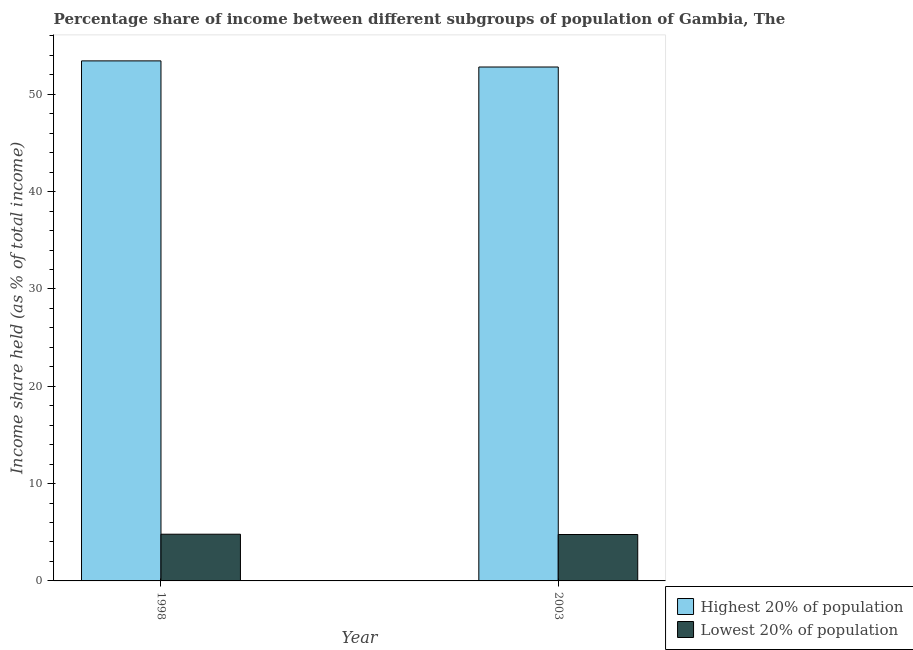How many different coloured bars are there?
Keep it short and to the point. 2. How many groups of bars are there?
Offer a very short reply. 2. Are the number of bars per tick equal to the number of legend labels?
Your response must be concise. Yes. How many bars are there on the 2nd tick from the left?
Make the answer very short. 2. What is the label of the 1st group of bars from the left?
Keep it short and to the point. 1998. In how many cases, is the number of bars for a given year not equal to the number of legend labels?
Keep it short and to the point. 0. Across all years, what is the maximum income share held by lowest 20% of the population?
Give a very brief answer. 4.8. Across all years, what is the minimum income share held by highest 20% of the population?
Offer a terse response. 52.81. In which year was the income share held by highest 20% of the population maximum?
Provide a succinct answer. 1998. What is the total income share held by lowest 20% of the population in the graph?
Your answer should be very brief. 9.57. What is the difference between the income share held by lowest 20% of the population in 1998 and that in 2003?
Make the answer very short. 0.03. What is the difference between the income share held by lowest 20% of the population in 1998 and the income share held by highest 20% of the population in 2003?
Give a very brief answer. 0.03. What is the average income share held by highest 20% of the population per year?
Make the answer very short. 53.12. In the year 2003, what is the difference between the income share held by highest 20% of the population and income share held by lowest 20% of the population?
Your response must be concise. 0. In how many years, is the income share held by highest 20% of the population greater than 22 %?
Provide a short and direct response. 2. What is the ratio of the income share held by highest 20% of the population in 1998 to that in 2003?
Offer a very short reply. 1.01. What does the 1st bar from the left in 2003 represents?
Make the answer very short. Highest 20% of population. What does the 2nd bar from the right in 1998 represents?
Offer a terse response. Highest 20% of population. Are all the bars in the graph horizontal?
Offer a very short reply. No. How many years are there in the graph?
Offer a very short reply. 2. Does the graph contain grids?
Your answer should be very brief. No. What is the title of the graph?
Provide a short and direct response. Percentage share of income between different subgroups of population of Gambia, The. Does "RDB concessional" appear as one of the legend labels in the graph?
Your answer should be very brief. No. What is the label or title of the X-axis?
Your response must be concise. Year. What is the label or title of the Y-axis?
Make the answer very short. Income share held (as % of total income). What is the Income share held (as % of total income) of Highest 20% of population in 1998?
Provide a short and direct response. 53.44. What is the Income share held (as % of total income) in Highest 20% of population in 2003?
Your answer should be compact. 52.81. What is the Income share held (as % of total income) in Lowest 20% of population in 2003?
Offer a terse response. 4.77. Across all years, what is the maximum Income share held (as % of total income) in Highest 20% of population?
Offer a very short reply. 53.44. Across all years, what is the maximum Income share held (as % of total income) in Lowest 20% of population?
Offer a very short reply. 4.8. Across all years, what is the minimum Income share held (as % of total income) in Highest 20% of population?
Provide a succinct answer. 52.81. Across all years, what is the minimum Income share held (as % of total income) of Lowest 20% of population?
Provide a succinct answer. 4.77. What is the total Income share held (as % of total income) in Highest 20% of population in the graph?
Keep it short and to the point. 106.25. What is the total Income share held (as % of total income) in Lowest 20% of population in the graph?
Ensure brevity in your answer.  9.57. What is the difference between the Income share held (as % of total income) in Highest 20% of population in 1998 and that in 2003?
Provide a succinct answer. 0.63. What is the difference between the Income share held (as % of total income) of Lowest 20% of population in 1998 and that in 2003?
Make the answer very short. 0.03. What is the difference between the Income share held (as % of total income) in Highest 20% of population in 1998 and the Income share held (as % of total income) in Lowest 20% of population in 2003?
Offer a very short reply. 48.67. What is the average Income share held (as % of total income) in Highest 20% of population per year?
Provide a short and direct response. 53.12. What is the average Income share held (as % of total income) of Lowest 20% of population per year?
Keep it short and to the point. 4.79. In the year 1998, what is the difference between the Income share held (as % of total income) in Highest 20% of population and Income share held (as % of total income) in Lowest 20% of population?
Give a very brief answer. 48.64. In the year 2003, what is the difference between the Income share held (as % of total income) of Highest 20% of population and Income share held (as % of total income) of Lowest 20% of population?
Your answer should be very brief. 48.04. What is the ratio of the Income share held (as % of total income) of Highest 20% of population in 1998 to that in 2003?
Provide a succinct answer. 1.01. What is the difference between the highest and the second highest Income share held (as % of total income) of Highest 20% of population?
Provide a succinct answer. 0.63. What is the difference between the highest and the second highest Income share held (as % of total income) in Lowest 20% of population?
Offer a terse response. 0.03. What is the difference between the highest and the lowest Income share held (as % of total income) of Highest 20% of population?
Ensure brevity in your answer.  0.63. What is the difference between the highest and the lowest Income share held (as % of total income) in Lowest 20% of population?
Your answer should be compact. 0.03. 